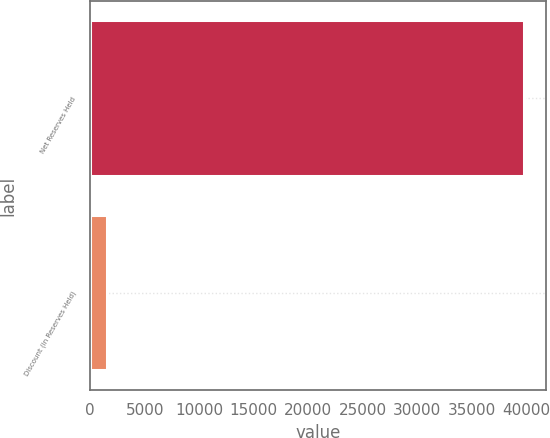Convert chart. <chart><loc_0><loc_0><loc_500><loc_500><bar_chart><fcel>Net Reserves Held<fcel>Discount (in Reserves Held)<nl><fcel>39850.8<fcel>1516<nl></chart> 